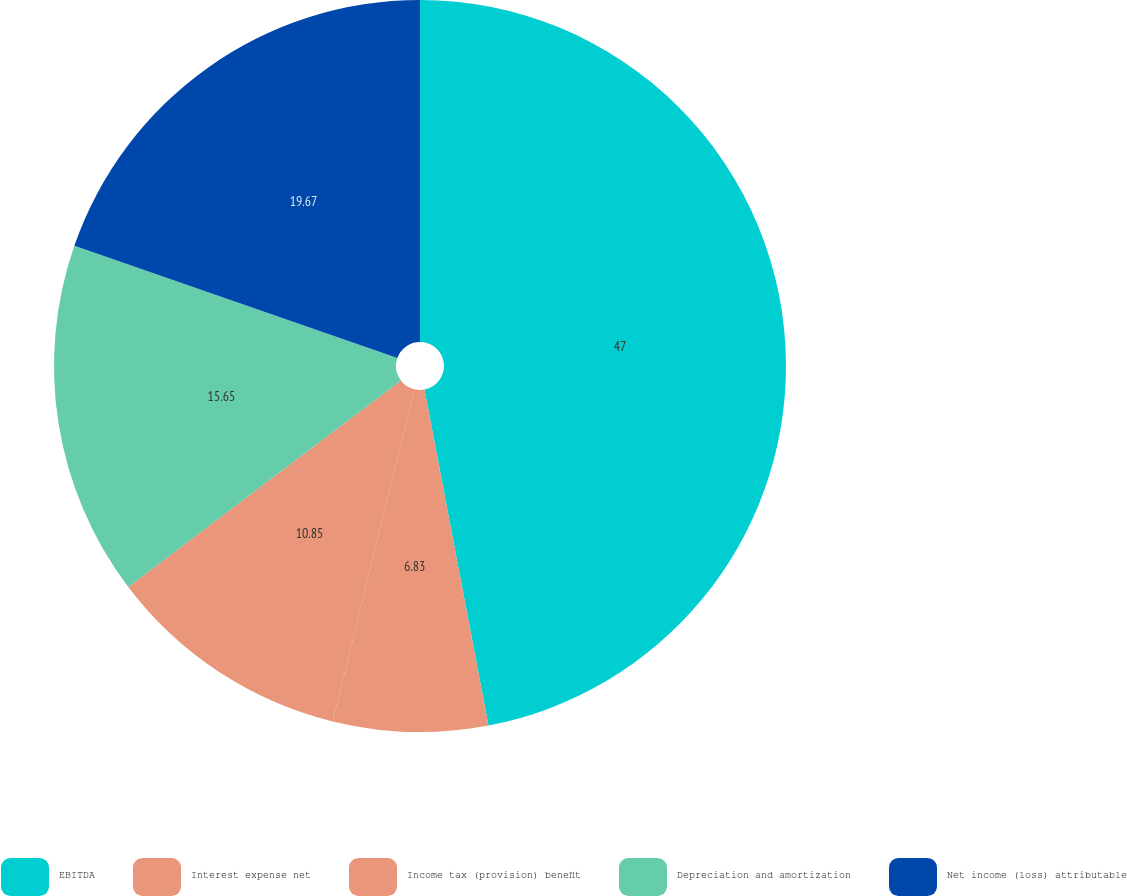Convert chart to OTSL. <chart><loc_0><loc_0><loc_500><loc_500><pie_chart><fcel>EBITDA<fcel>Interest expense net<fcel>Income tax (provision) benefit<fcel>Depreciation and amortization<fcel>Net income (loss) attributable<nl><fcel>47.01%<fcel>6.83%<fcel>10.85%<fcel>15.65%<fcel>19.67%<nl></chart> 